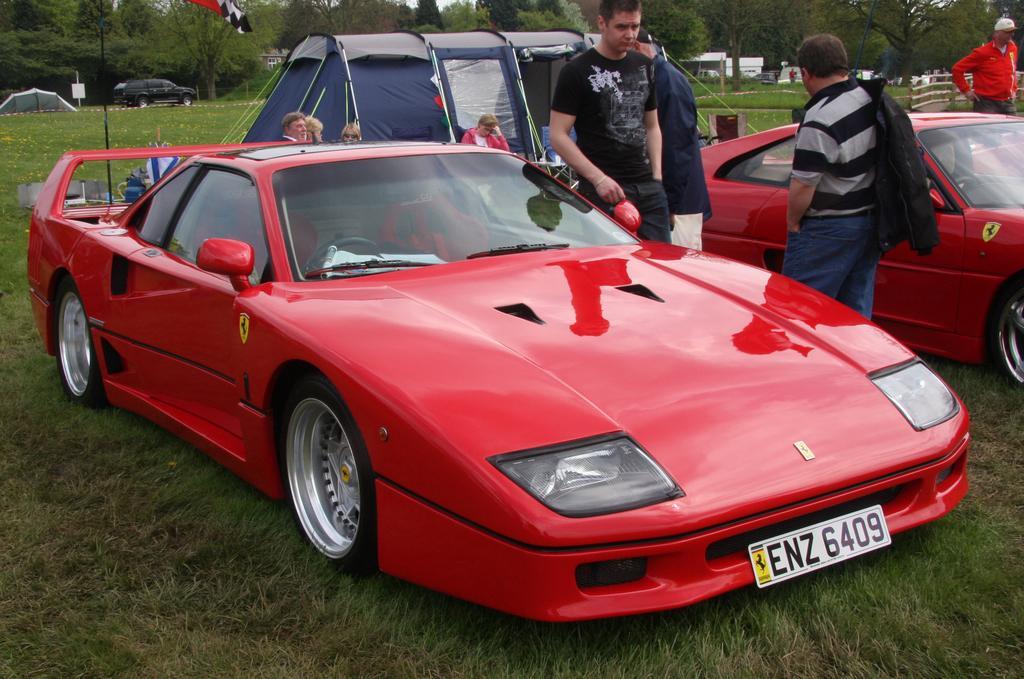Can you describe this image briefly? In the image there are two red cars on the grassland and few men standing on either side of it and in the back there is a tent with few people sitting in front of it, over the background there are trees. 